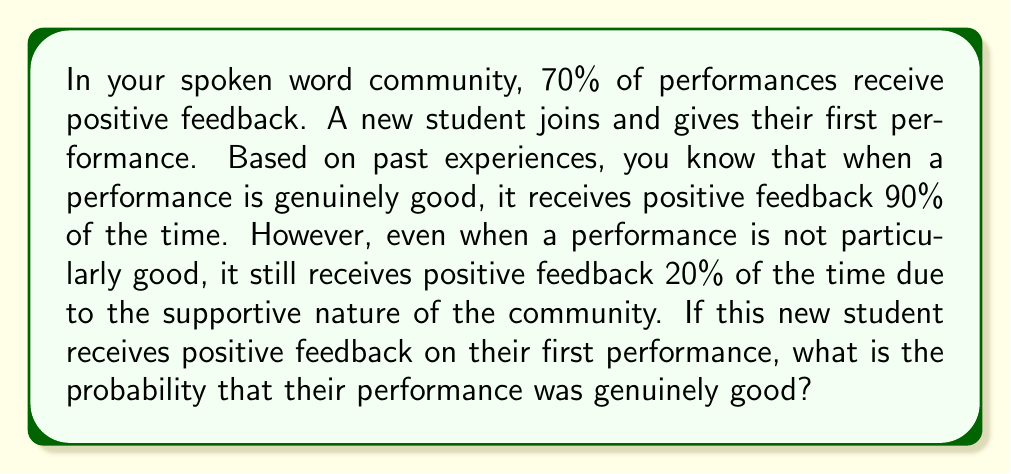Give your solution to this math problem. Let's approach this problem using Bayes' theorem. We'll define the following events:

$G$: The performance is genuinely good
$P$: The performance receives positive feedback

We're given the following probabilities:

$P(G) = 0.70$ (prior probability of a performance being good)
$P(P|G) = 0.90$ (probability of positive feedback given a good performance)
$P(P|\neg G) = 0.20$ (probability of positive feedback given a not-good performance)

We want to find $P(G|P)$, the probability that the performance was genuinely good given that it received positive feedback.

Bayes' theorem states:

$$P(G|P) = \frac{P(P|G) \cdot P(G)}{P(P)}$$

To calculate $P(P)$, we use the law of total probability:

$$P(P) = P(P|G) \cdot P(G) + P(P|\neg G) \cdot P(\neg G)$$

Step 1: Calculate $P(\neg G)$
$P(\neg G) = 1 - P(G) = 1 - 0.70 = 0.30$

Step 2: Calculate $P(P)$
$P(P) = 0.90 \cdot 0.70 + 0.20 \cdot 0.30 = 0.63 + 0.06 = 0.69$

Step 3: Apply Bayes' theorem
$$P(G|P) = \frac{0.90 \cdot 0.70}{0.69} \approx 0.9130$$

Therefore, the probability that the performance was genuinely good, given that it received positive feedback, is approximately 0.9130 or 91.30%.
Answer: $P(G|P) \approx 0.9130$ or 91.30% 